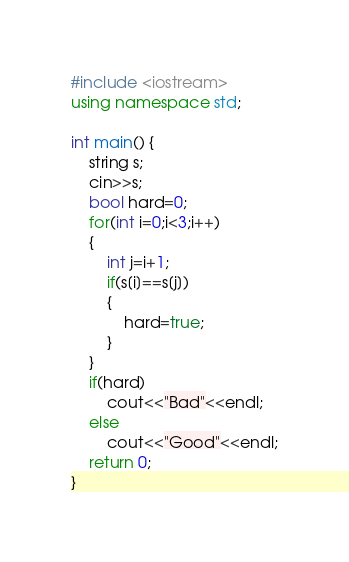Convert code to text. <code><loc_0><loc_0><loc_500><loc_500><_C++_>#include <iostream>
using namespace std;

int main() {
	string s;
	cin>>s;
	bool hard=0;
	for(int i=0;i<3;i++)
    {
        int j=i+1;
        if(s[i]==s[j])
        {
            hard=true;
        }
    }
    if(hard)
        cout<<"Bad"<<endl;
    else
        cout<<"Good"<<endl;
	return 0;
}
</code> 